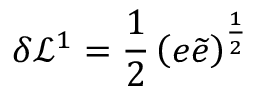<formula> <loc_0><loc_0><loc_500><loc_500>\delta \mathcal { L } ^ { 1 } = \frac { 1 } { 2 } \left ( e \widetilde { e } \right ) ^ { \frac { 1 } { 2 } }</formula> 